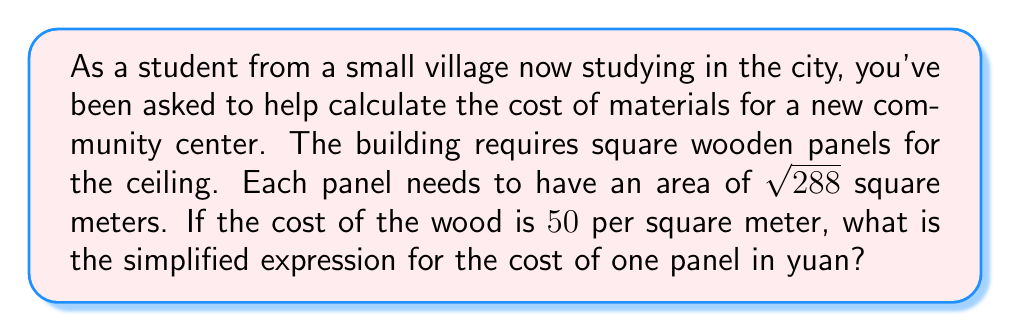Give your solution to this math problem. Let's approach this step-by-step:

1) First, we need to simplify $\sqrt{288}$:
   
   $\sqrt{288} = \sqrt{16 \times 18} = \sqrt{16} \times \sqrt{18} = 4\sqrt{18}$

2) We can further simplify $\sqrt{18}$:
   
   $\sqrt{18} = \sqrt{9 \times 2} = \sqrt{9} \times \sqrt{2} = 3\sqrt{2}$

3) So, $\sqrt{288} = 4 \times 3\sqrt{2} = 12\sqrt{2}$ square meters

4) Now, we need to calculate the cost. The cost is $¥50$ per square meter, so we multiply:
   
   $50 \times 12\sqrt{2} = 600\sqrt{2}$ yuan

Therefore, the simplified expression for the cost of one panel is $600\sqrt{2}$ yuan.
Answer: $600\sqrt{2}$ yuan 